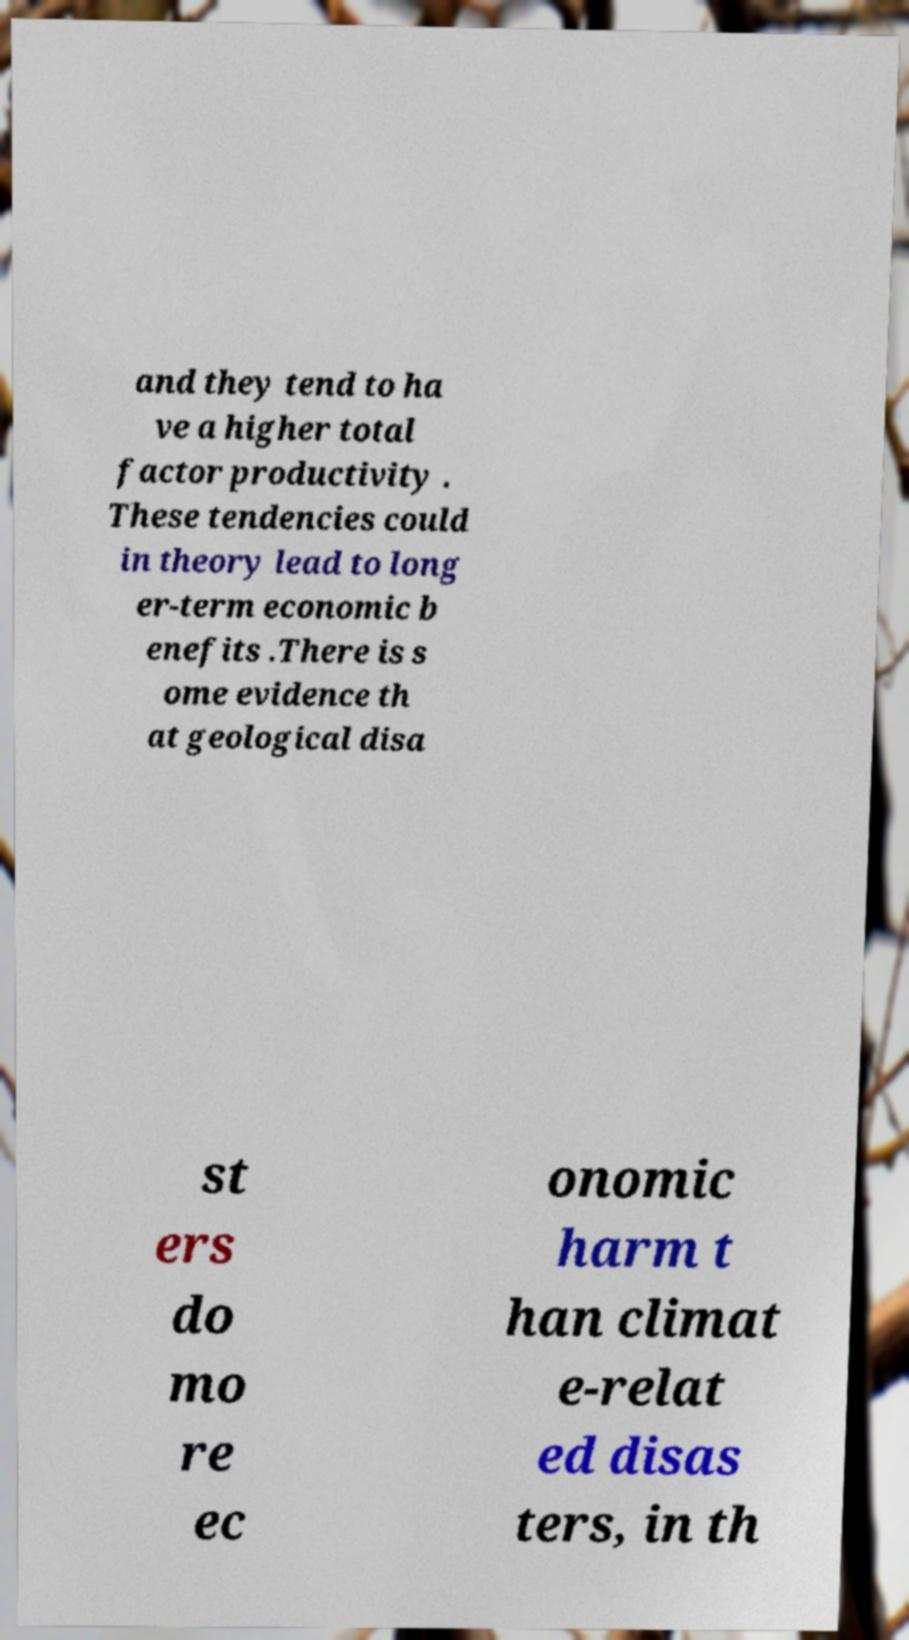Can you accurately transcribe the text from the provided image for me? and they tend to ha ve a higher total factor productivity . These tendencies could in theory lead to long er-term economic b enefits .There is s ome evidence th at geological disa st ers do mo re ec onomic harm t han climat e-relat ed disas ters, in th 